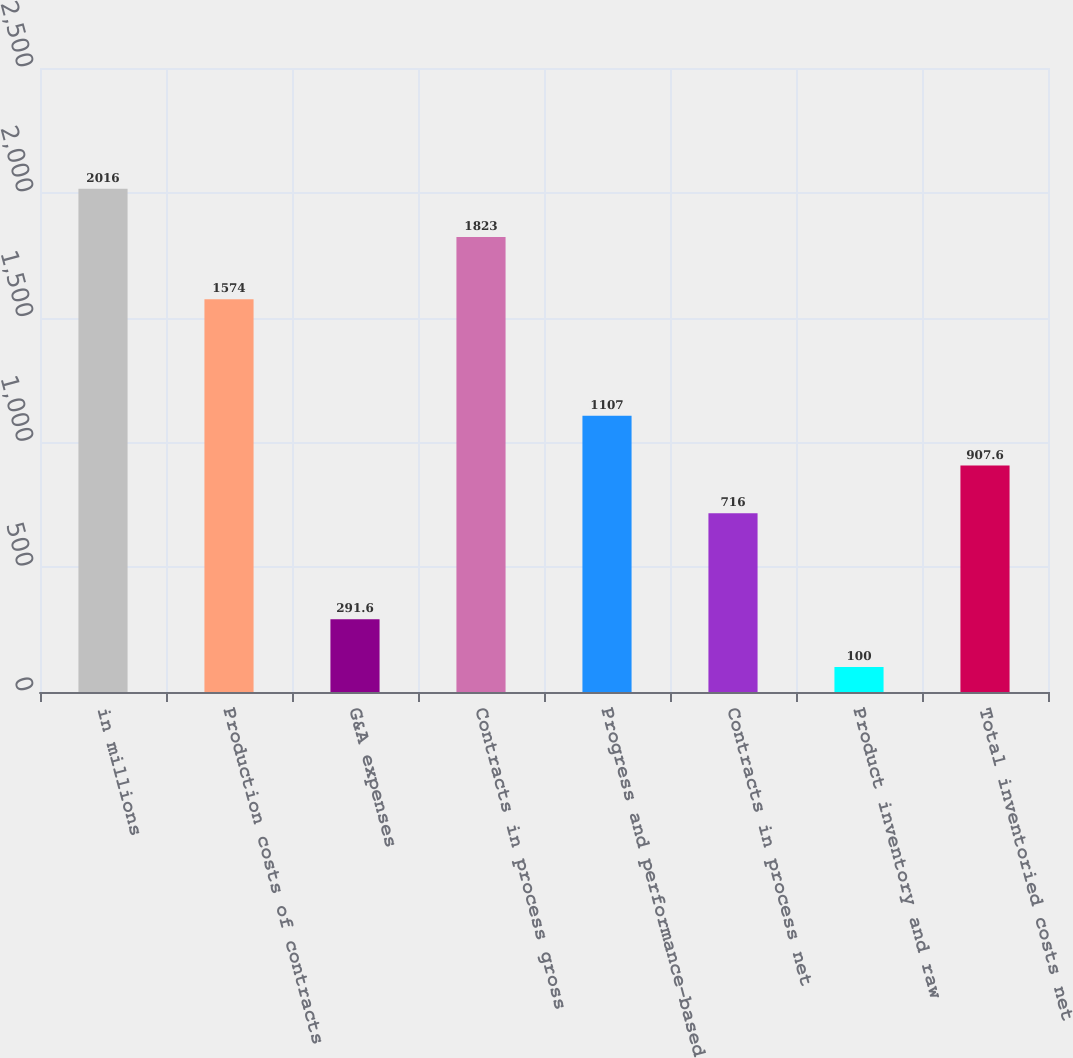Convert chart. <chart><loc_0><loc_0><loc_500><loc_500><bar_chart><fcel>in millions<fcel>Production costs of contracts<fcel>G&A expenses<fcel>Contracts in process gross<fcel>Progress and performance-based<fcel>Contracts in process net<fcel>Product inventory and raw<fcel>Total inventoried costs net<nl><fcel>2016<fcel>1574<fcel>291.6<fcel>1823<fcel>1107<fcel>716<fcel>100<fcel>907.6<nl></chart> 